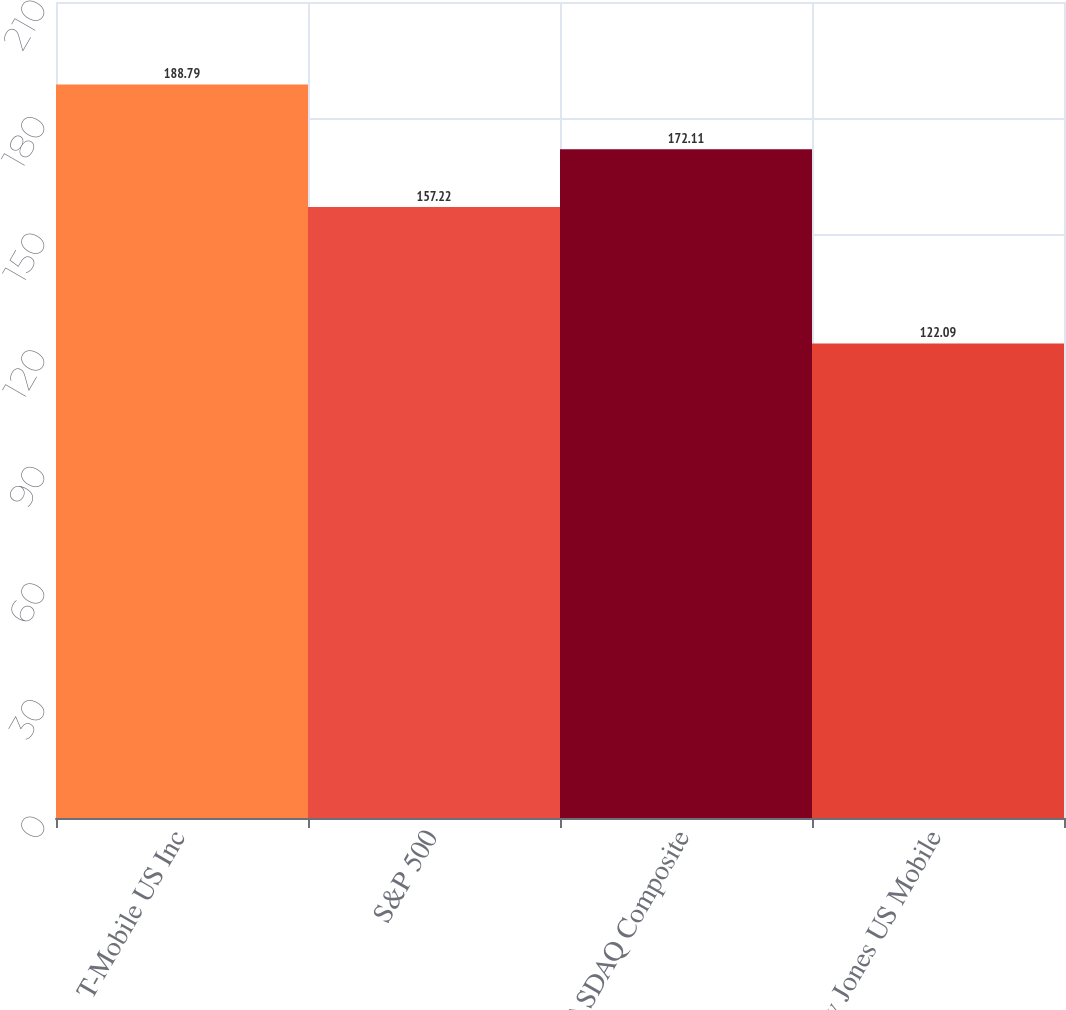<chart> <loc_0><loc_0><loc_500><loc_500><bar_chart><fcel>T-Mobile US Inc<fcel>S&P 500<fcel>NASDAQ Composite<fcel>Dow Jones US Mobile<nl><fcel>188.79<fcel>157.22<fcel>172.11<fcel>122.09<nl></chart> 